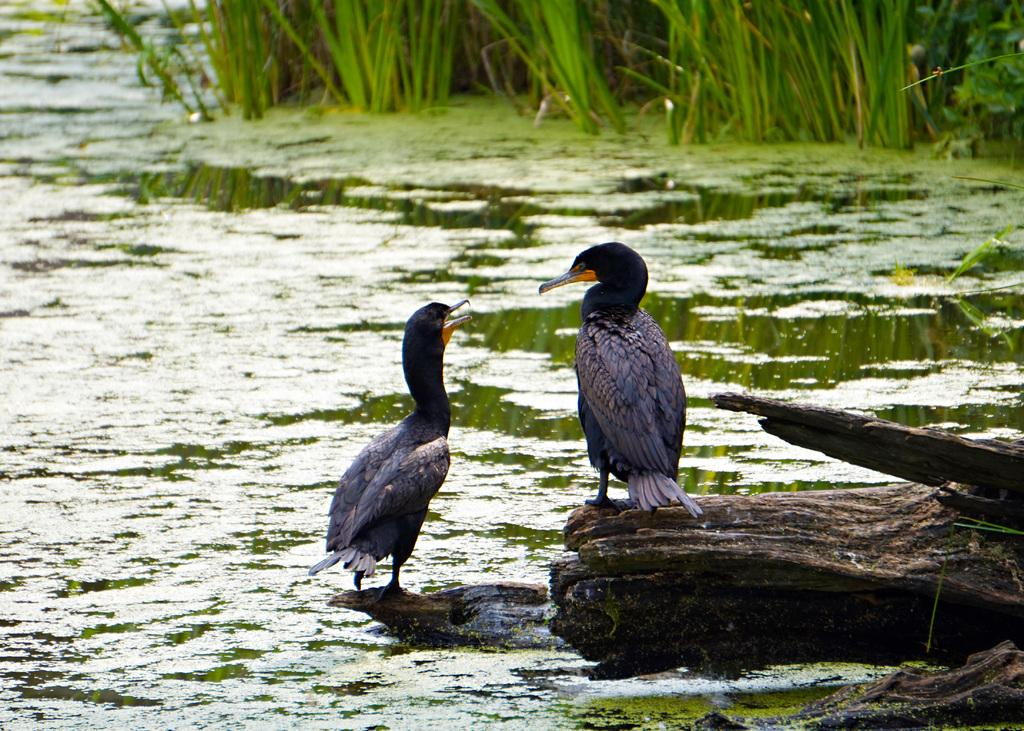What animals can be seen on the trunks in the image? There are birds on the trunks in the image. What type of vegetation is present in the image? There are plants and grass in the image. What body of water is visible in the image? There is a lake visible in the image. What type of popcorn is being served during the rainstorm in the image? There is no popcorn or rainstorm present in the image; it features birds on trunks, plants, grass, and a lake. 